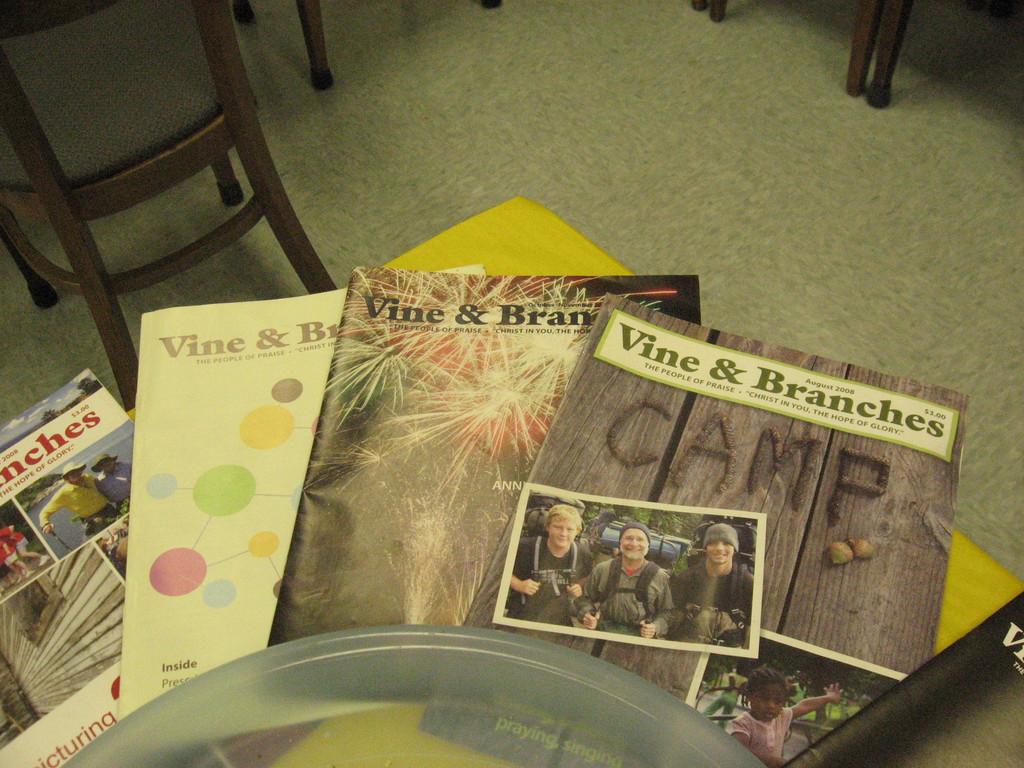What word is spelled using food on the top magazine?
Ensure brevity in your answer.  Camp. 